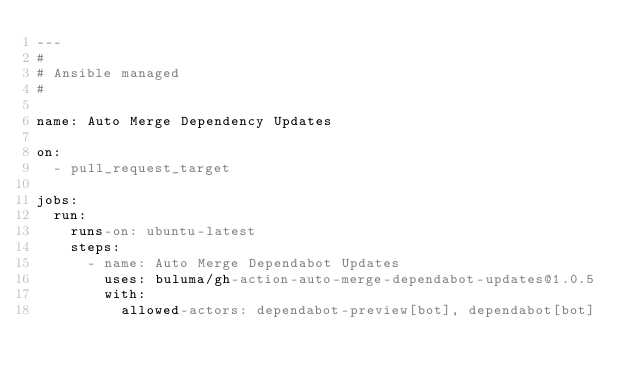Convert code to text. <code><loc_0><loc_0><loc_500><loc_500><_YAML_>---
#
# Ansible managed
#

name: Auto Merge Dependency Updates

on:
  - pull_request_target

jobs:
  run:
    runs-on: ubuntu-latest
    steps:
      - name: Auto Merge Dependabot Updates
        uses: buluma/gh-action-auto-merge-dependabot-updates@1.0.5
        with:
          allowed-actors: dependabot-preview[bot], dependabot[bot]
</code> 